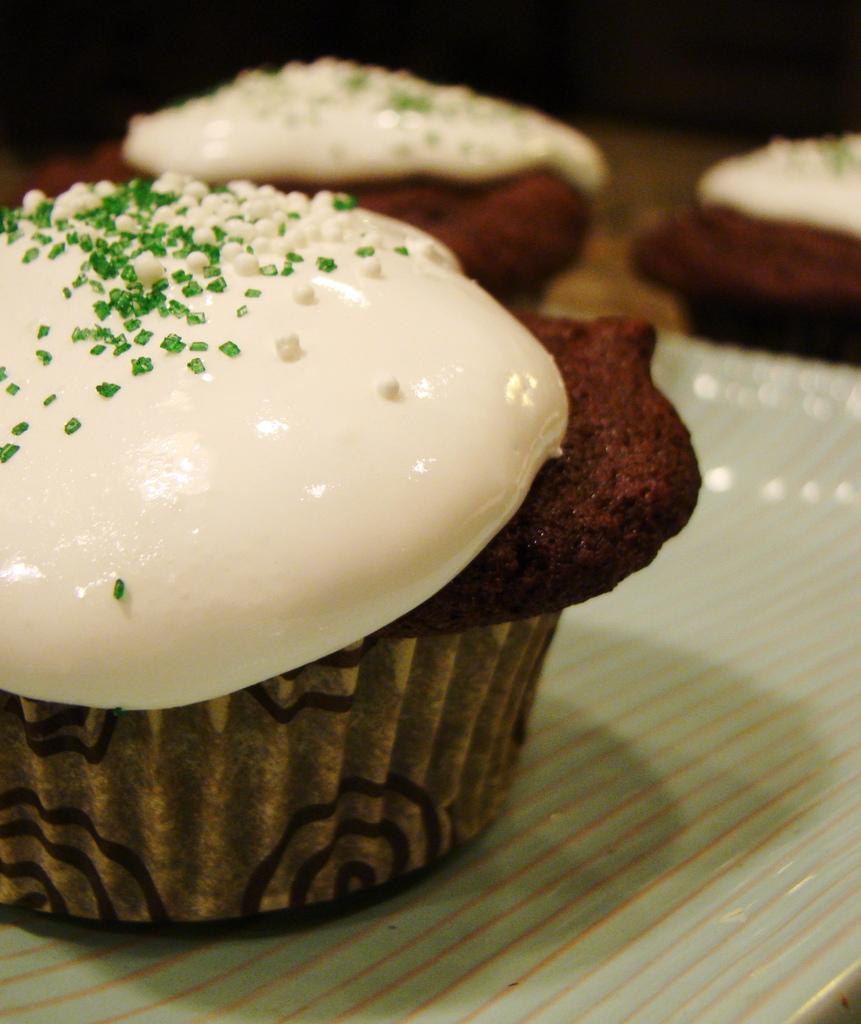How would you summarize this image in a sentence or two? In this picture we can see cupcakes on a tray and in the background it is dark. 